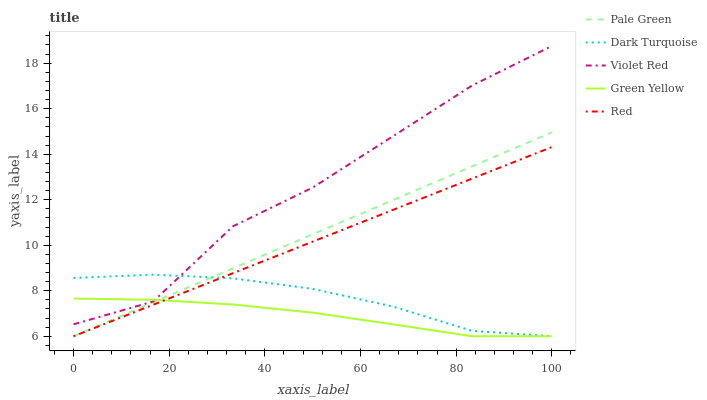Does Green Yellow have the minimum area under the curve?
Answer yes or no. Yes. Does Violet Red have the maximum area under the curve?
Answer yes or no. Yes. Does Pale Green have the minimum area under the curve?
Answer yes or no. No. Does Pale Green have the maximum area under the curve?
Answer yes or no. No. Is Red the smoothest?
Answer yes or no. Yes. Is Violet Red the roughest?
Answer yes or no. Yes. Is Pale Green the smoothest?
Answer yes or no. No. Is Pale Green the roughest?
Answer yes or no. No. Does Dark Turquoise have the lowest value?
Answer yes or no. Yes. Does Violet Red have the lowest value?
Answer yes or no. No. Does Violet Red have the highest value?
Answer yes or no. Yes. Does Pale Green have the highest value?
Answer yes or no. No. Is Pale Green less than Violet Red?
Answer yes or no. Yes. Is Violet Red greater than Red?
Answer yes or no. Yes. Does Dark Turquoise intersect Green Yellow?
Answer yes or no. Yes. Is Dark Turquoise less than Green Yellow?
Answer yes or no. No. Is Dark Turquoise greater than Green Yellow?
Answer yes or no. No. Does Pale Green intersect Violet Red?
Answer yes or no. No. 